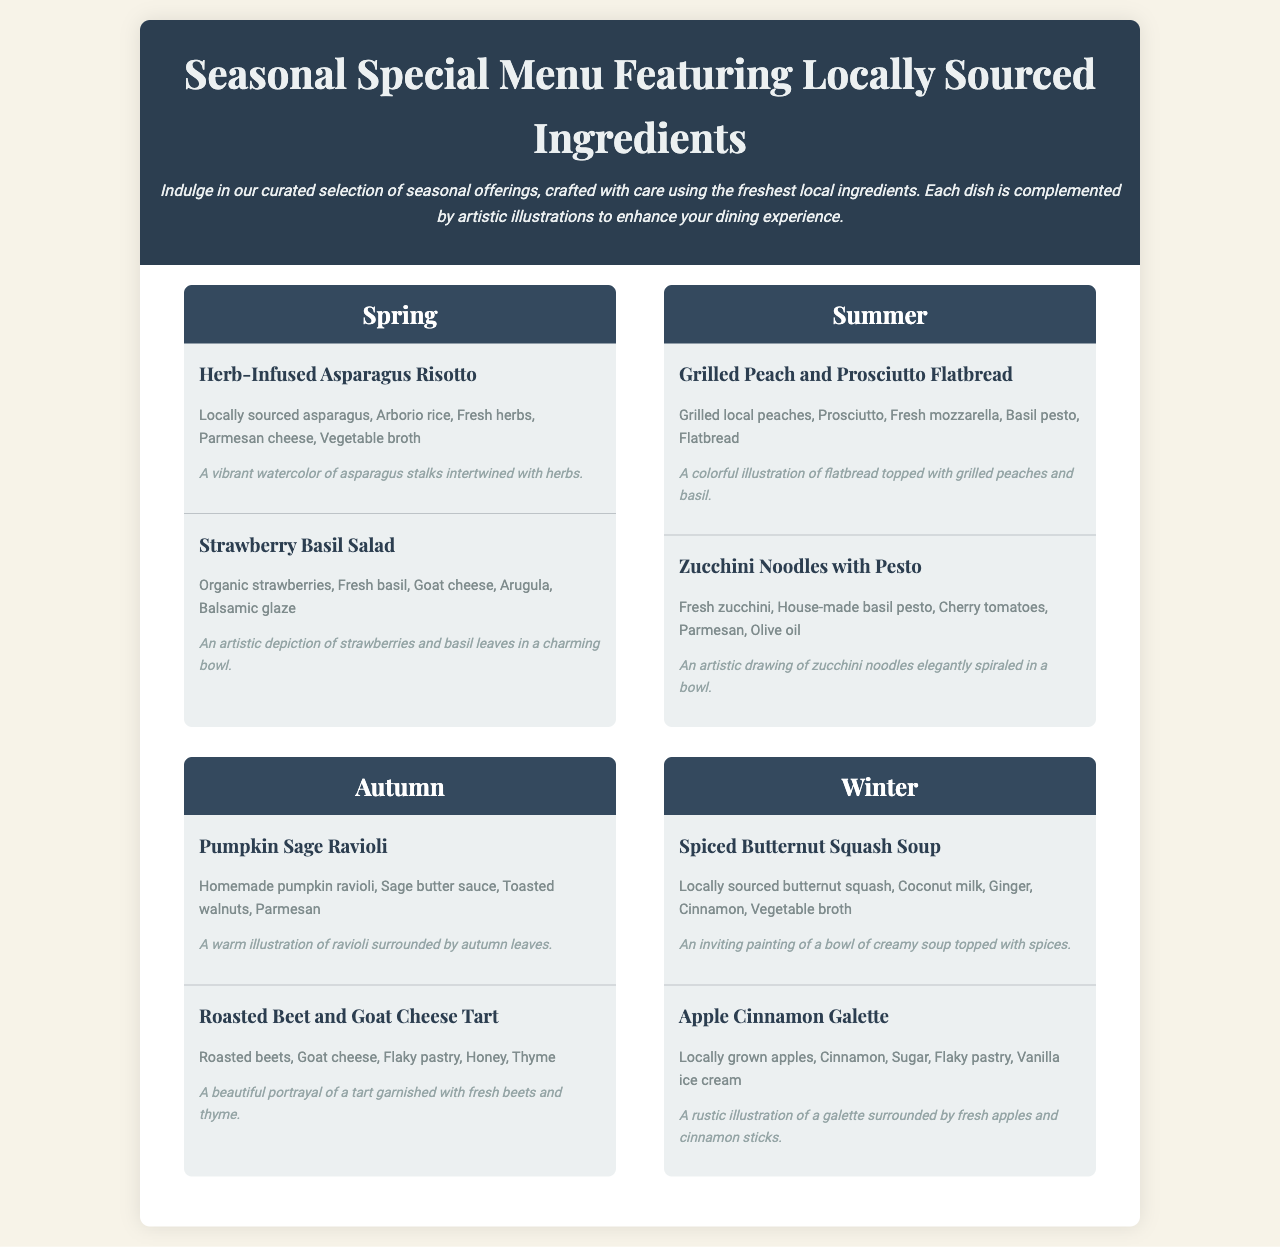what are the dishes featured in spring? The spring dishes listed in the menu are Herb-Infused Asparagus Risotto and Strawberry Basil Salad.
Answer: Herb-Infused Asparagus Risotto, Strawberry Basil Salad how many dishes are there for each season? Each season has two dishes featured in the menu.
Answer: Two what is the main ingredient in the Zucchini Noodles with Pesto? The main ingredient in the Zucchini Noodles with Pesto is fresh zucchini.
Answer: Fresh zucchini which season features the dish Roasted Beet and Goat Cheese Tart? The Roasted Beet and Goat Cheese Tart is featured in the autumn season.
Answer: Autumn what are the key ingredients in the Spiced Butternut Squash Soup? The key ingredients in the Spiced Butternut Squash Soup are butternut squash, coconut milk, ginger, cinnamon, and vegetable broth.
Answer: Butternut squash, coconut milk, ginger, cinnamon, vegetable broth how is the Apple Cinnamon Galette best served according to the menu? The Apple Cinnamon Galette is best served with vanilla ice cream.
Answer: Vanilla ice cream what type of illustrations accompany the dishes? The dishes are accompanied by artistic illustrations, enhancing the dining experience.
Answer: Artistic illustrations which herb is used in the Pumpkin Sage Ravioli dish? The herb used in the Pumpkin Sage Ravioli dish is sage.
Answer: Sage 